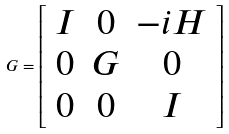<formula> <loc_0><loc_0><loc_500><loc_500>G = \left [ \begin{array} { c c c } I & 0 & - i H \\ 0 & G & 0 \\ 0 & 0 & I \\ \end{array} \right ]</formula> 